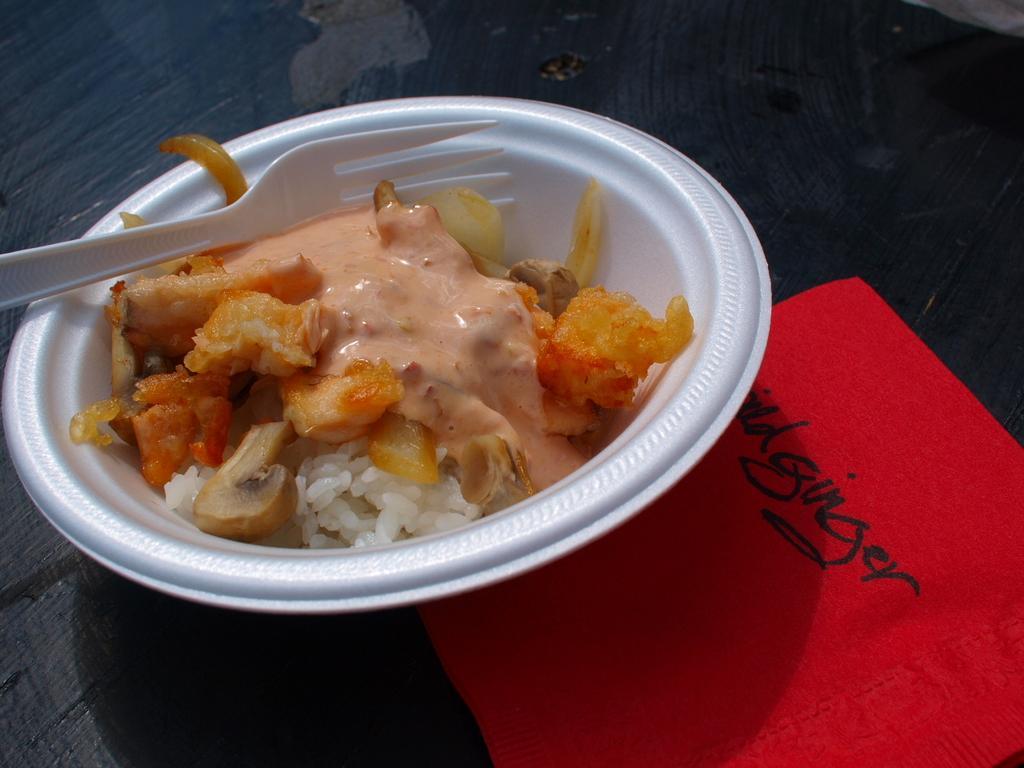Please provide a concise description of this image. In this image there is a food item kept in a white color bowl and there is a fork in to this bowl and there is a cloth which is in red color is at bottom right corner of this image. 